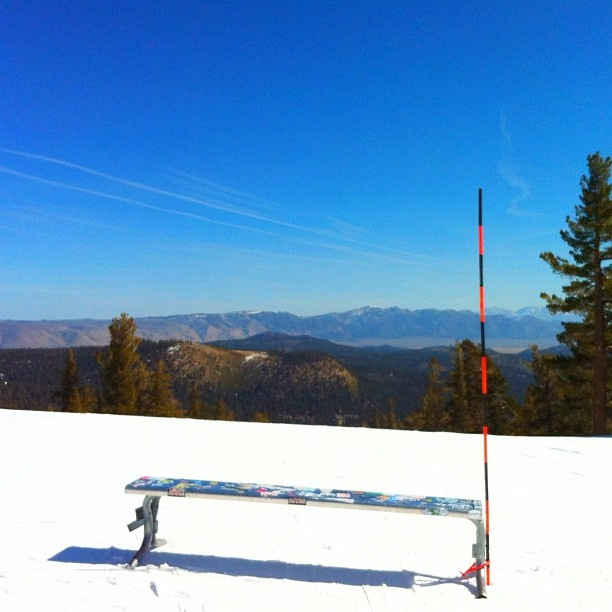Describe the objects in this image and their specific colors. I can see a bench in blue, white, darkgray, and gray tones in this image. 